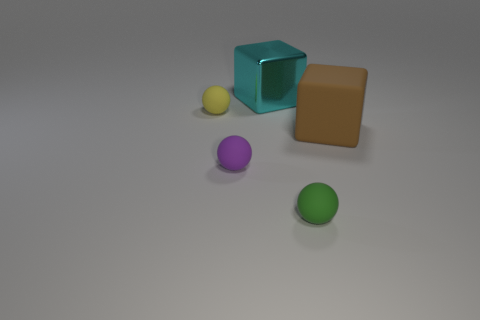Add 4 blue matte spheres. How many objects exist? 9 Subtract all yellow balls. How many balls are left? 2 Subtract 1 spheres. How many spheres are left? 2 Subtract all large cyan cylinders. Subtract all cyan shiny objects. How many objects are left? 4 Add 1 small purple rubber balls. How many small purple rubber balls are left? 2 Add 2 yellow balls. How many yellow balls exist? 3 Subtract 1 brown blocks. How many objects are left? 4 Subtract all spheres. How many objects are left? 2 Subtract all gray spheres. Subtract all blue cubes. How many spheres are left? 3 